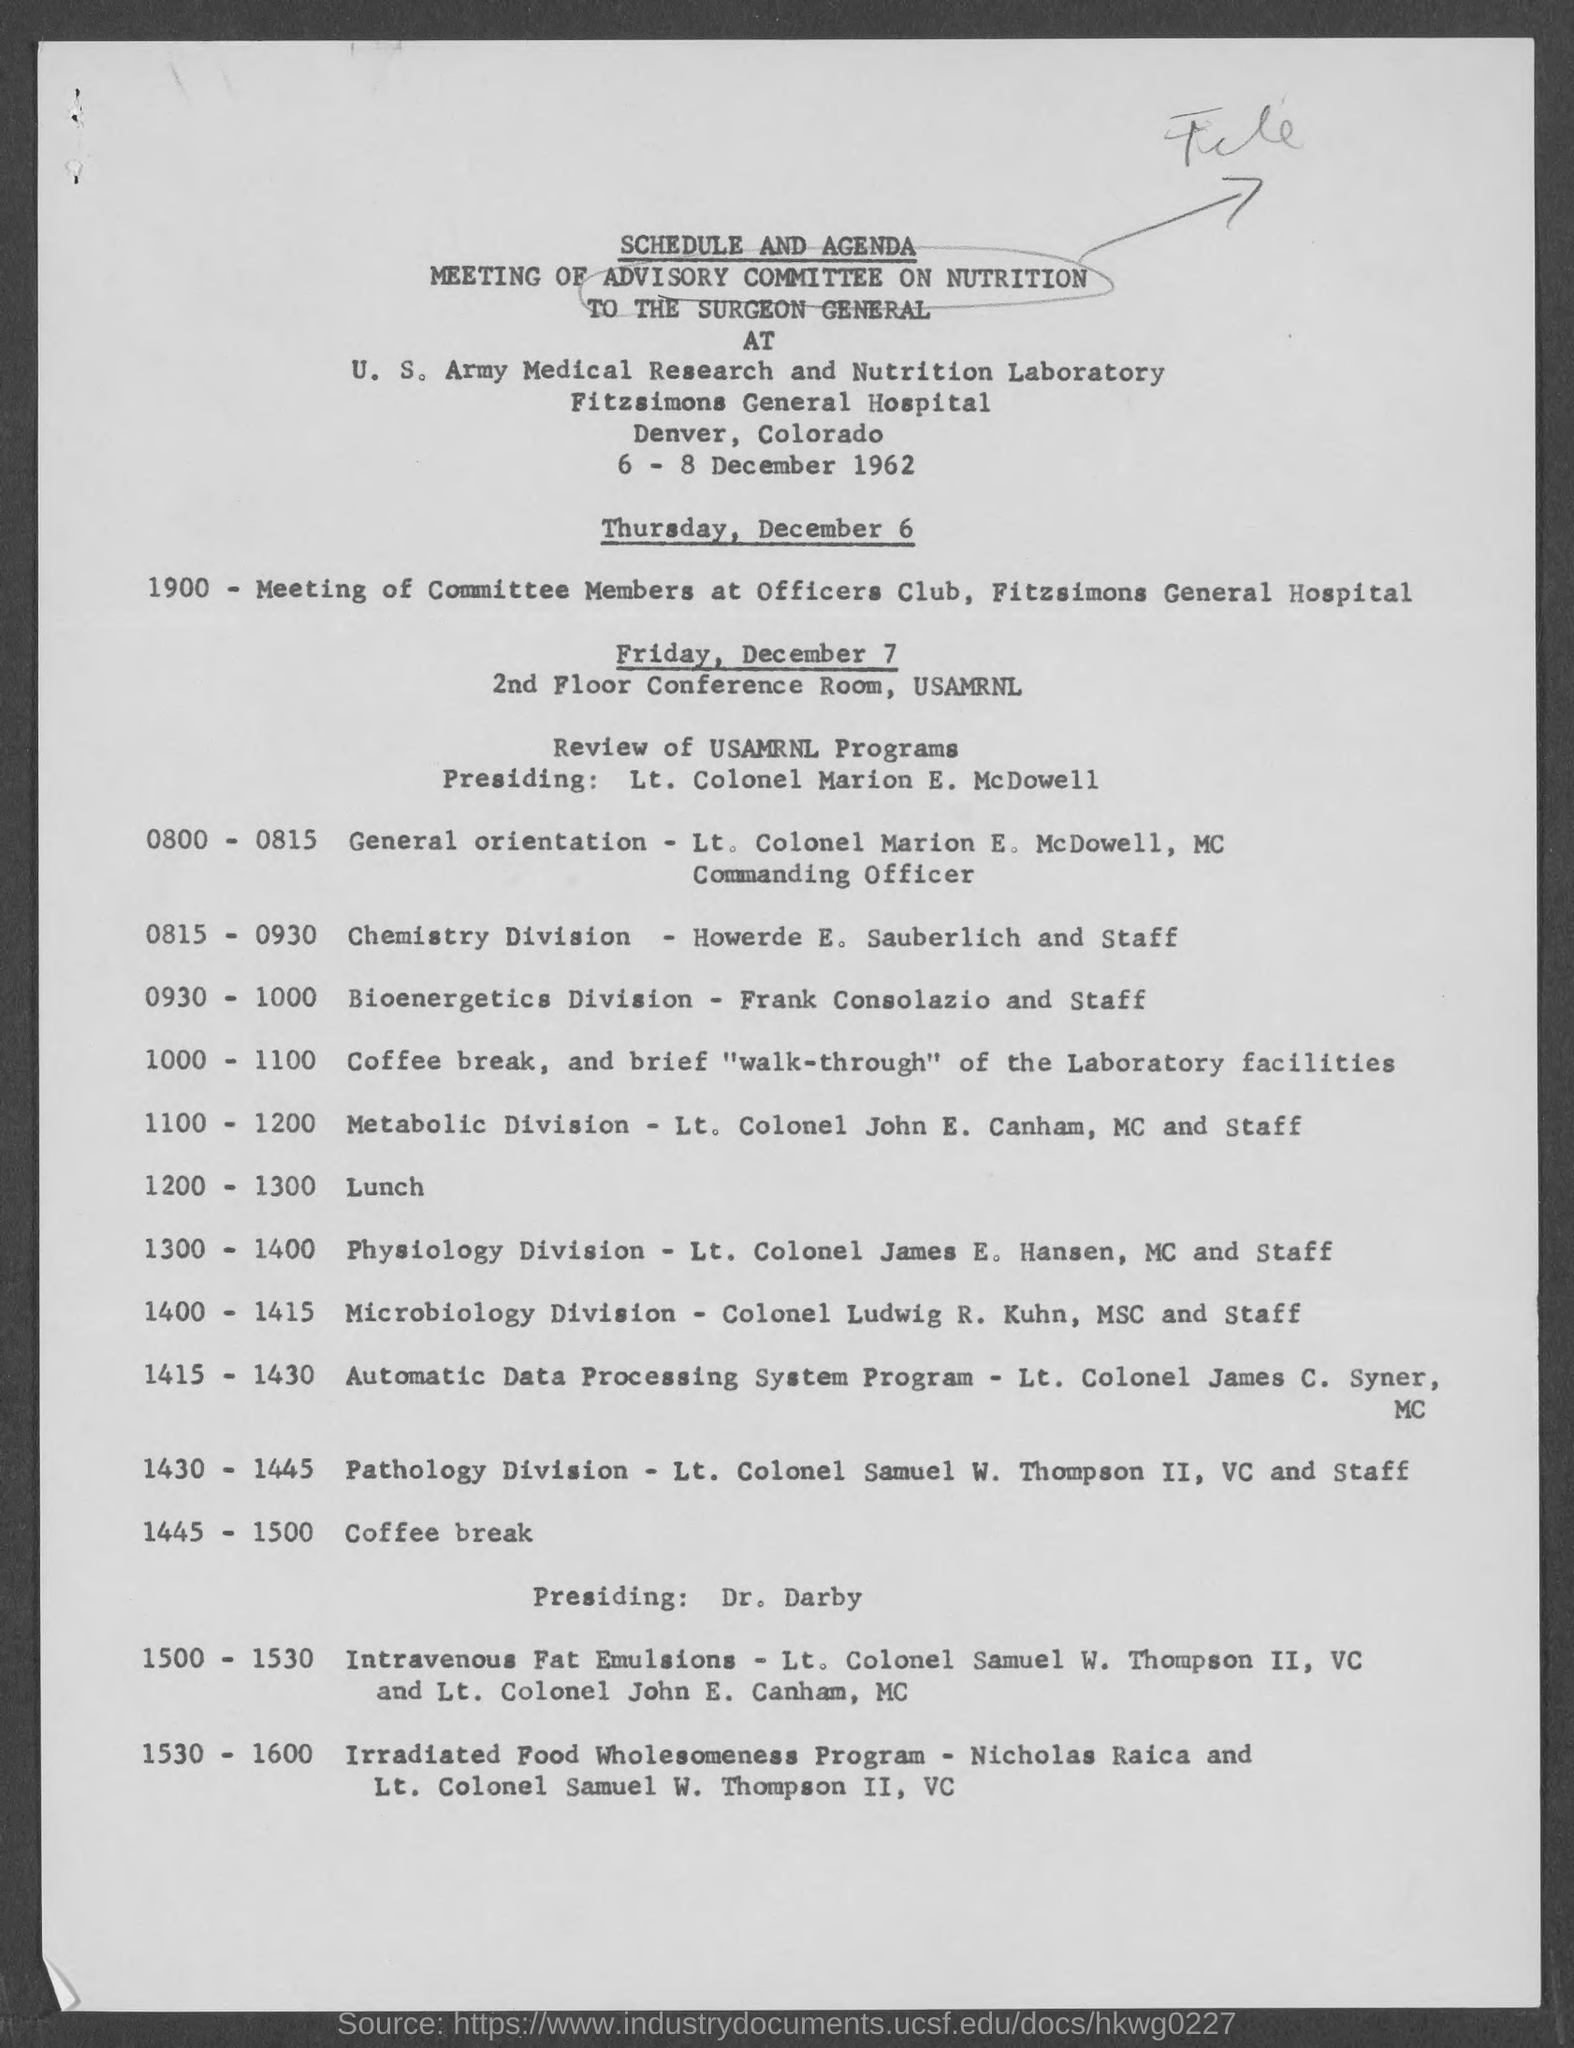What is the name of the hospital mentioned in the given page ?
Your answer should be compact. Fitzsimons general hospital. What is the schedule at the time of 1900 on thursday, december 6 ?
Offer a very short reply. Meeting of Committee Members at Officers Club, Fitzsimons General Hospital. What is the scheduled division at the time of 1100-1200 mentioned in the given program ?
Your response must be concise. Metabolic Division. What is the schedule at the time of 1200 - 1300 ?
Keep it short and to the point. Lunch. What is the schedule at the time of 1445 - 1500 ?
Provide a succinct answer. Coffee break. What is the scheduled division at the time of 1300 - 1400 ?
Give a very brief answer. Physiology Division. What is the schedule at the time of 1000 - 1100 ?
Your answer should be very brief. Coffee break, and brief "walk-through" of the Laboratory facilities. 